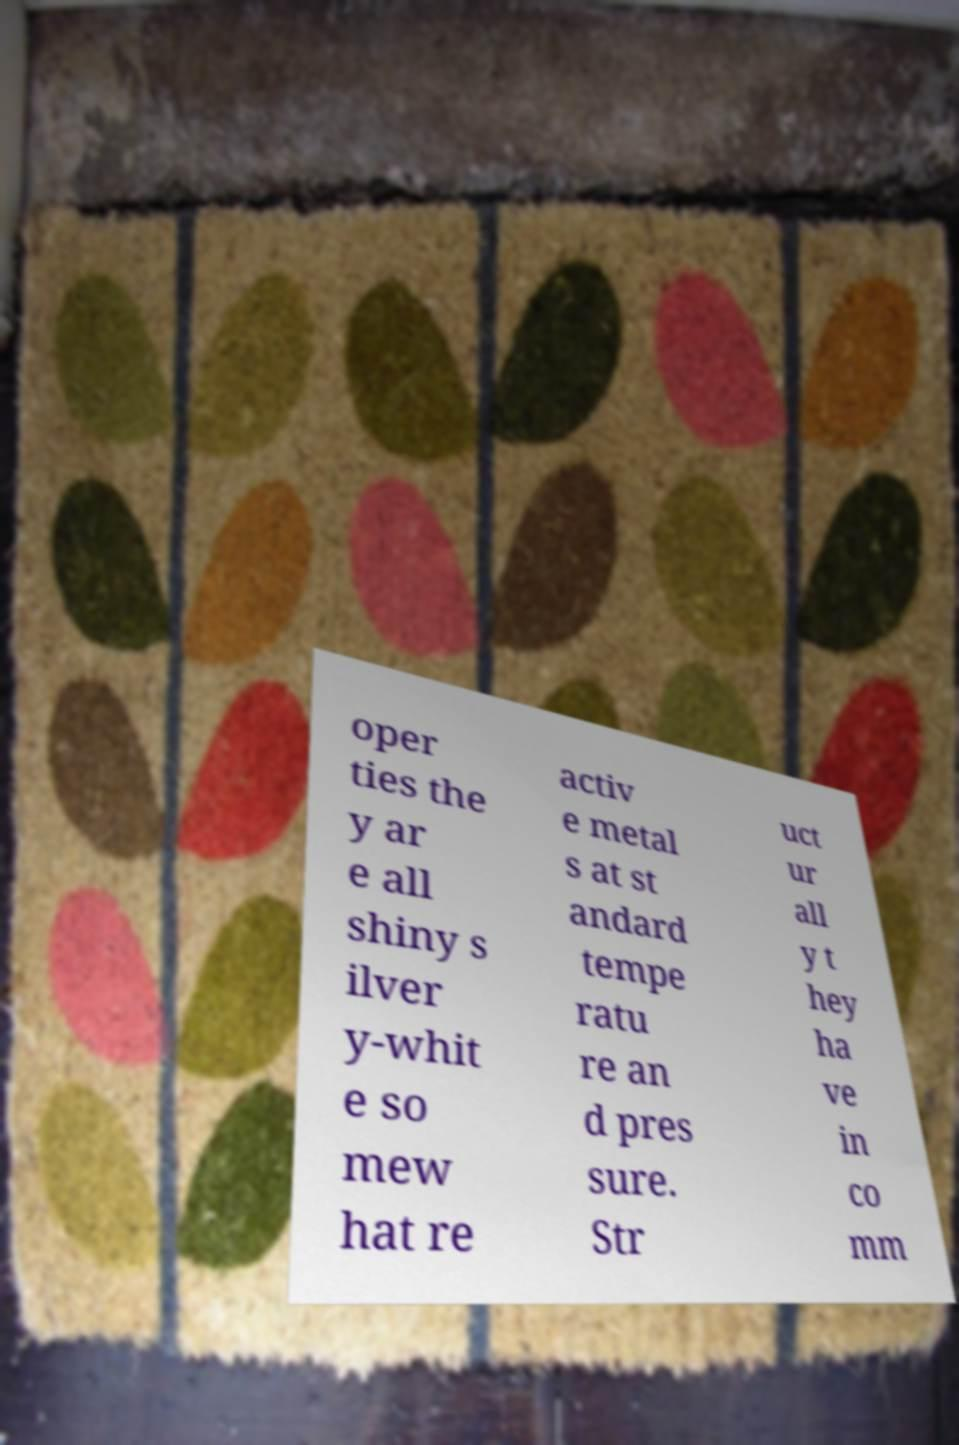Can you accurately transcribe the text from the provided image for me? oper ties the y ar e all shiny s ilver y-whit e so mew hat re activ e metal s at st andard tempe ratu re an d pres sure. Str uct ur all y t hey ha ve in co mm 